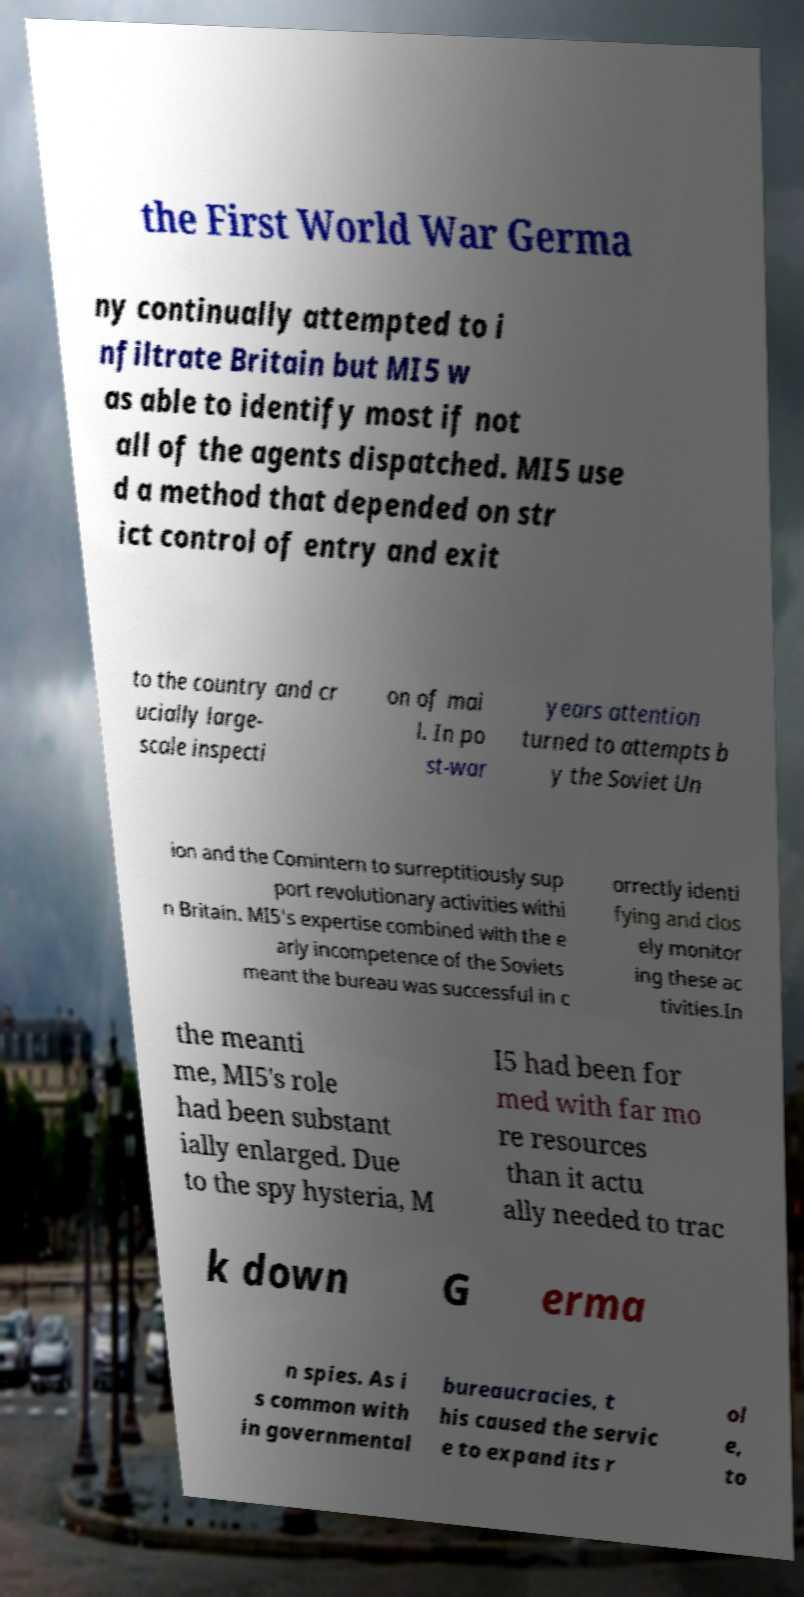For documentation purposes, I need the text within this image transcribed. Could you provide that? the First World War Germa ny continually attempted to i nfiltrate Britain but MI5 w as able to identify most if not all of the agents dispatched. MI5 use d a method that depended on str ict control of entry and exit to the country and cr ucially large- scale inspecti on of mai l. In po st-war years attention turned to attempts b y the Soviet Un ion and the Comintern to surreptitiously sup port revolutionary activities withi n Britain. MI5's expertise combined with the e arly incompetence of the Soviets meant the bureau was successful in c orrectly identi fying and clos ely monitor ing these ac tivities.In the meanti me, MI5's role had been substant ially enlarged. Due to the spy hysteria, M I5 had been for med with far mo re resources than it actu ally needed to trac k down G erma n spies. As i s common with in governmental bureaucracies, t his caused the servic e to expand its r ol e, to 